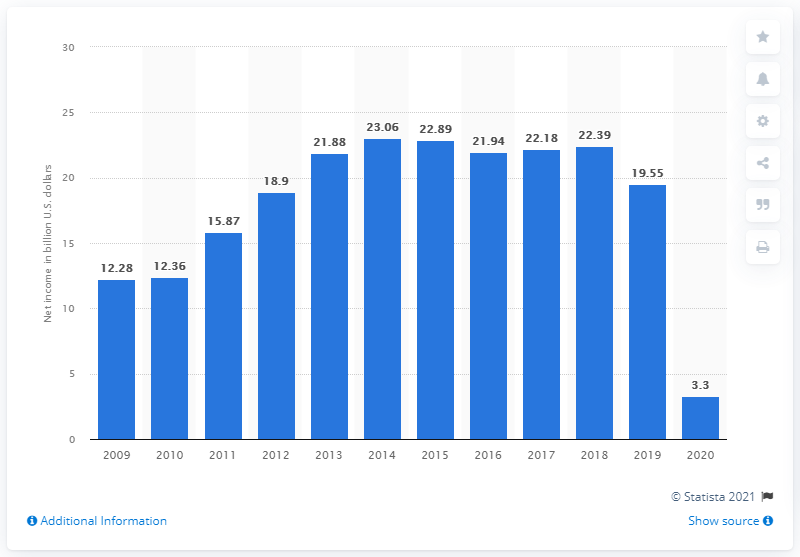Highlight a few significant elements in this photo. The net income of Wells Fargo in dollars in 2020 was 3.3 million. 